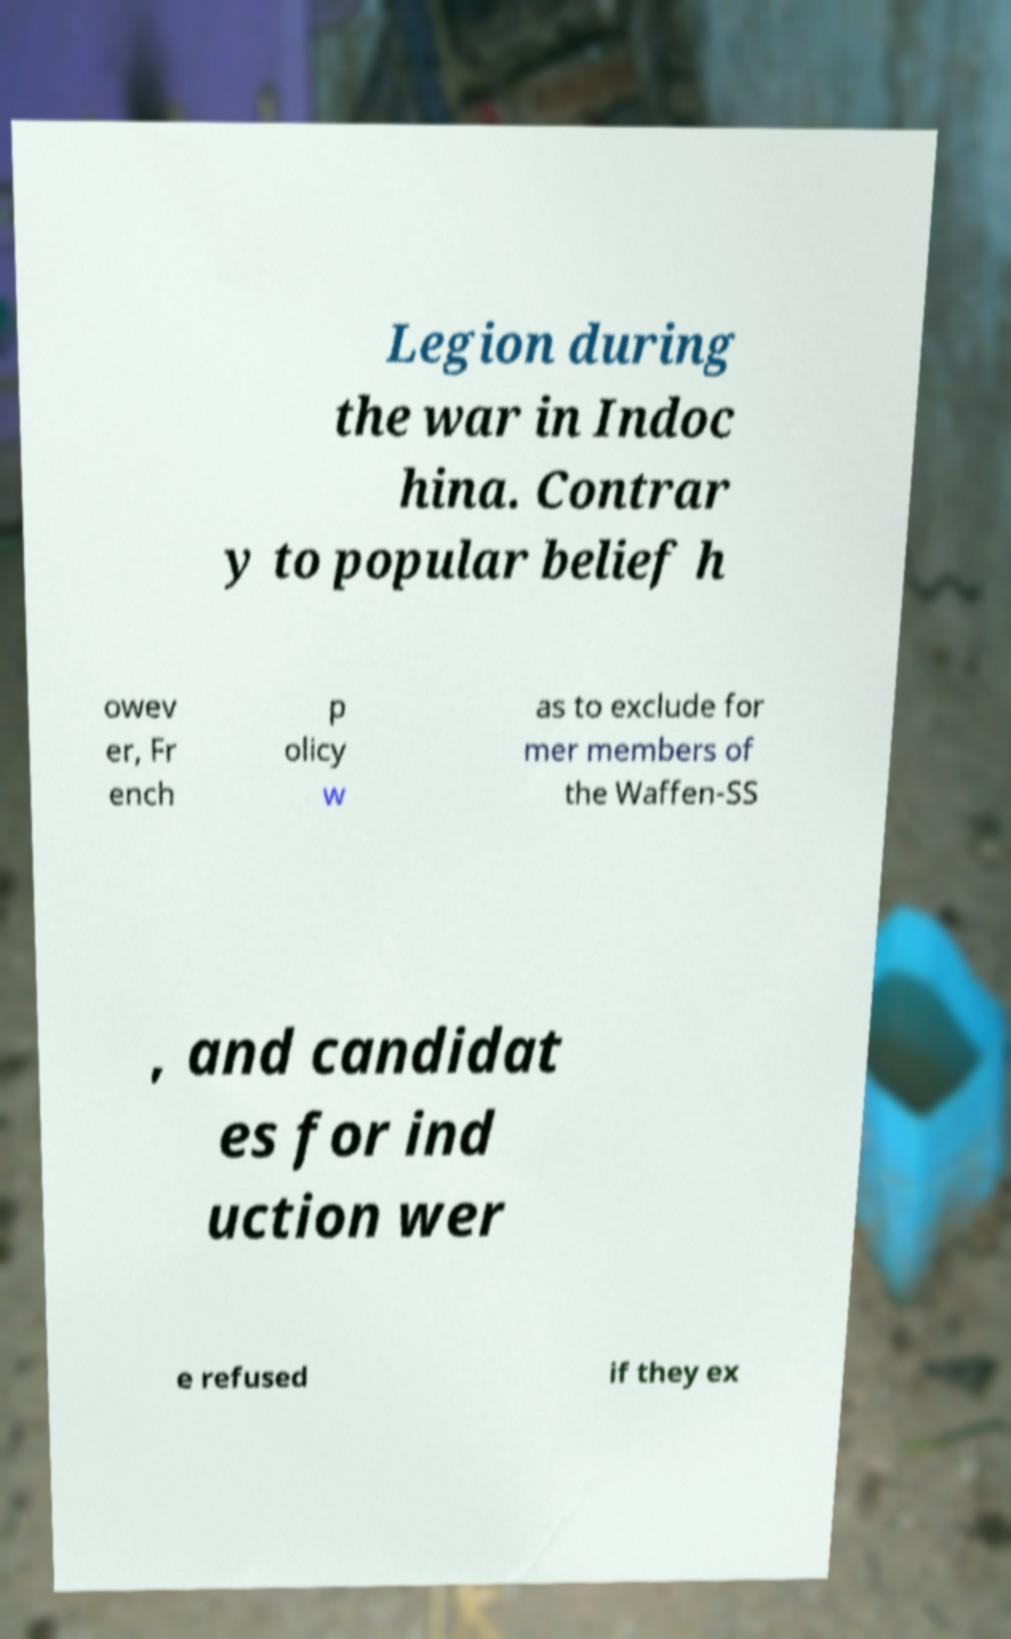What messages or text are displayed in this image? I need them in a readable, typed format. Legion during the war in Indoc hina. Contrar y to popular belief h owev er, Fr ench p olicy w as to exclude for mer members of the Waffen-SS , and candidat es for ind uction wer e refused if they ex 